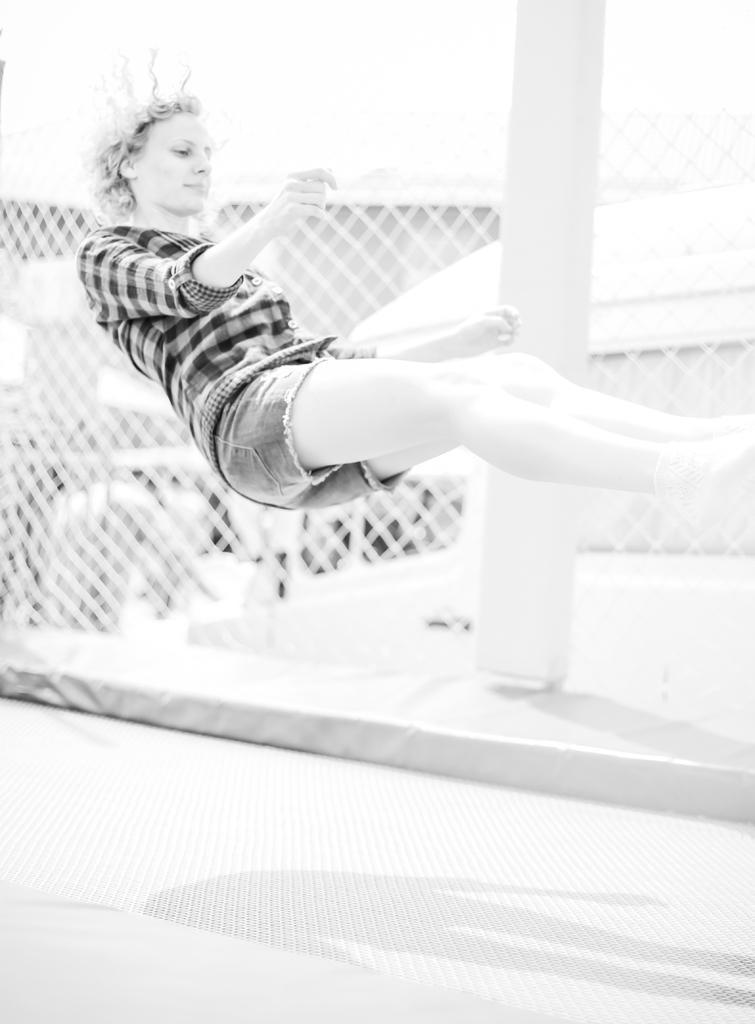Describe this image in one or two sentences. In the center of the image we can see a person. In the background there is a pole and we can see a net. At the bottom there is a road. 